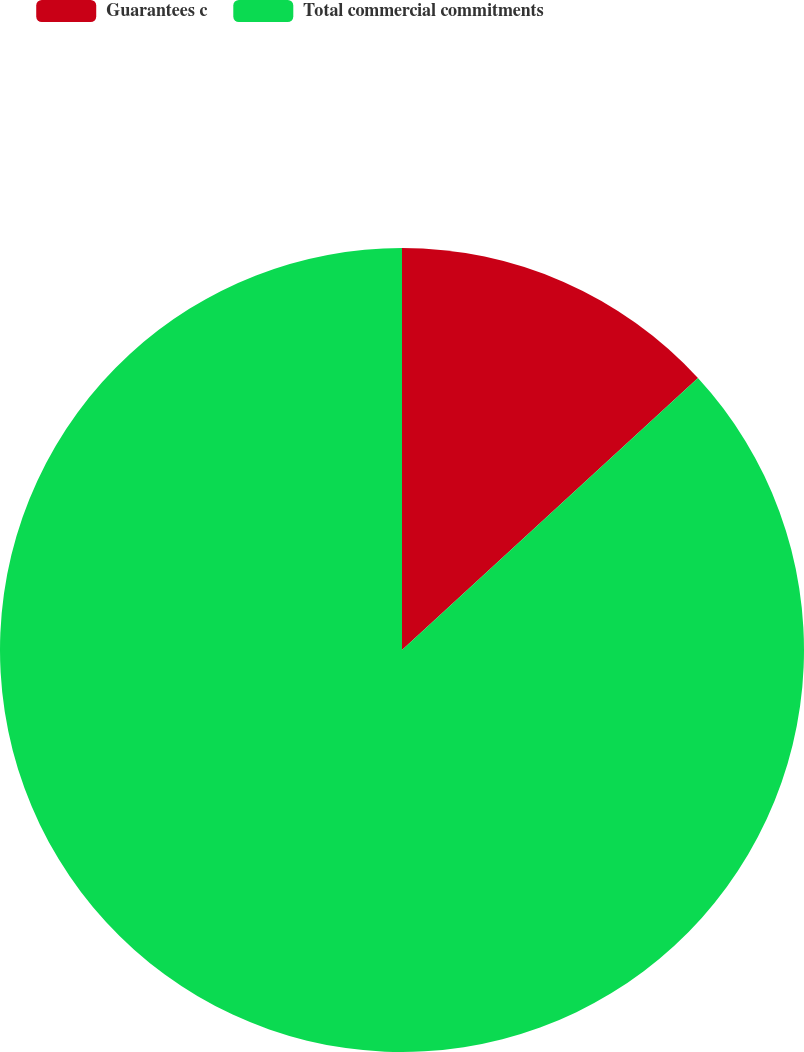<chart> <loc_0><loc_0><loc_500><loc_500><pie_chart><fcel>Guarantees c<fcel>Total commercial commitments<nl><fcel>13.17%<fcel>86.83%<nl></chart> 